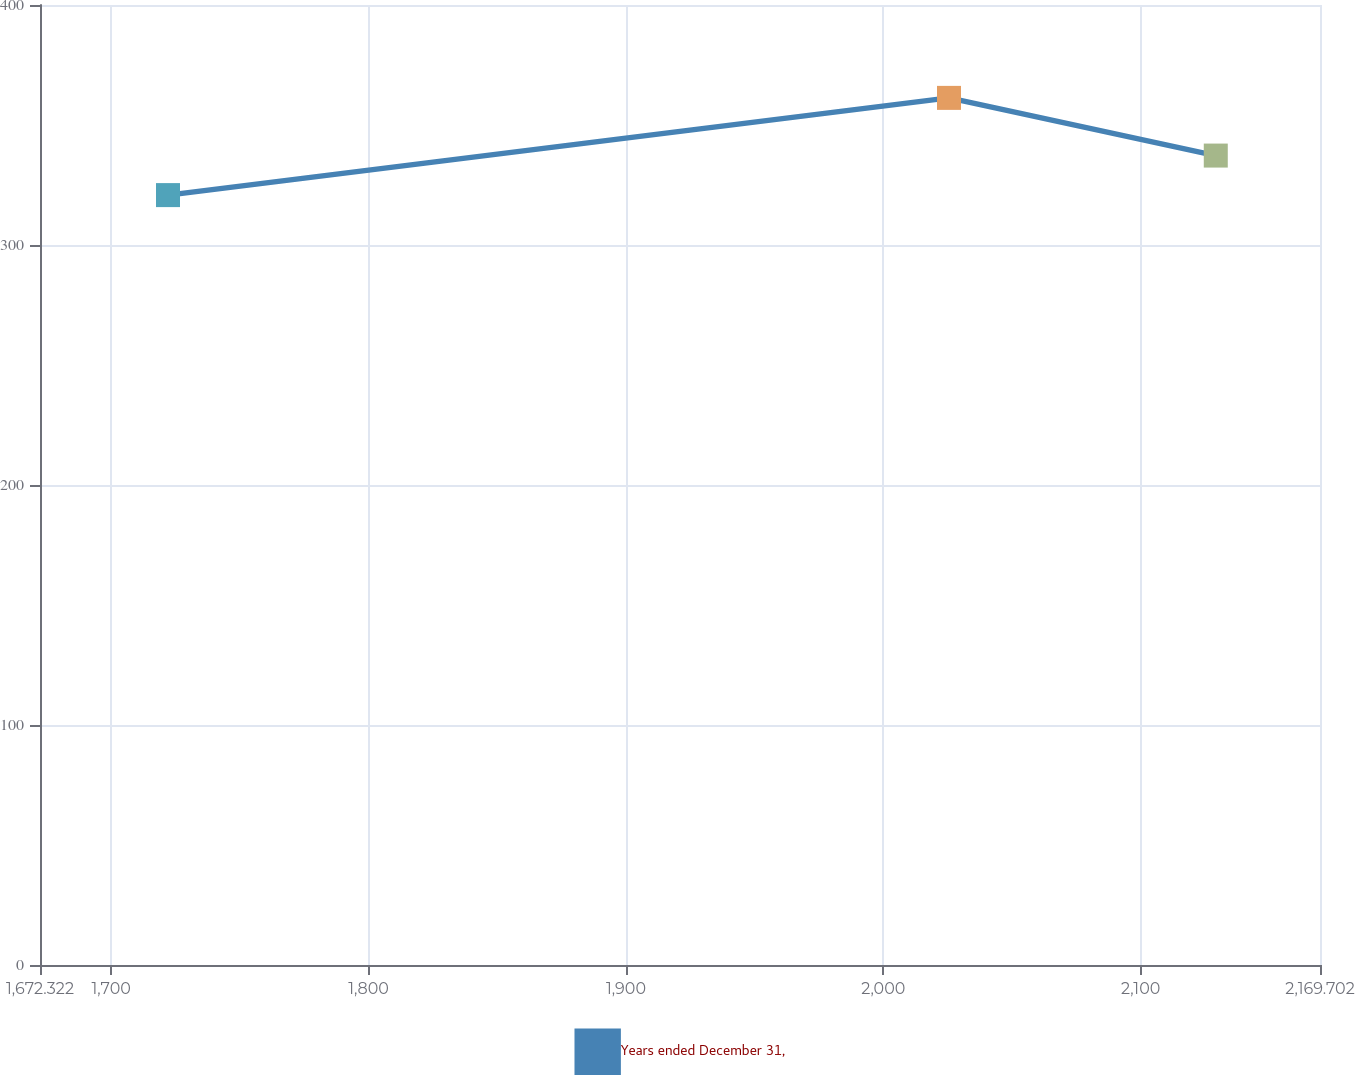<chart> <loc_0><loc_0><loc_500><loc_500><line_chart><ecel><fcel>Years ended December 31,<nl><fcel>1722.06<fcel>320.79<nl><fcel>2025.53<fcel>361.3<nl><fcel>2129.2<fcel>337.26<nl><fcel>2174.32<fcel>343.66<nl><fcel>2219.44<fcel>380.81<nl></chart> 